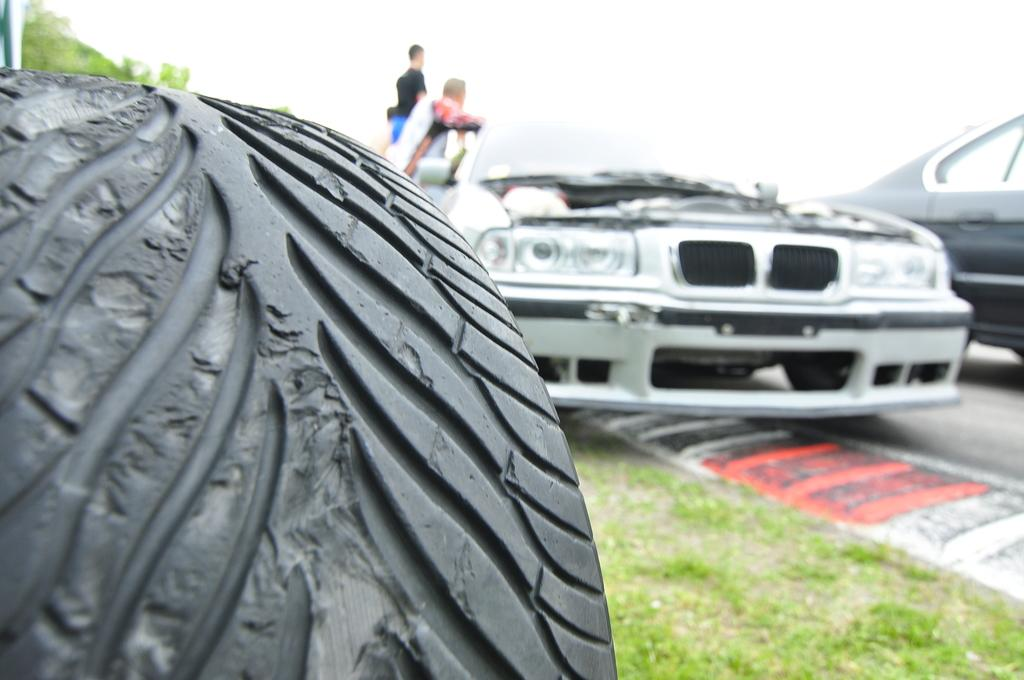What object is located on the left side of the image? There is a Tyre on the left side of the image. What can be seen on the right side of the image? There are cars on the road on the right side of the image. What is visible in the background of the image? There are persons and a tree in the background of the image, as well as the sky. What type of copper material can be seen in the image? There is no copper material present in the image. How many wings are visible on the persons in the background of the image? The persons in the background do not have wings, as they are not depicted as having any such features. 